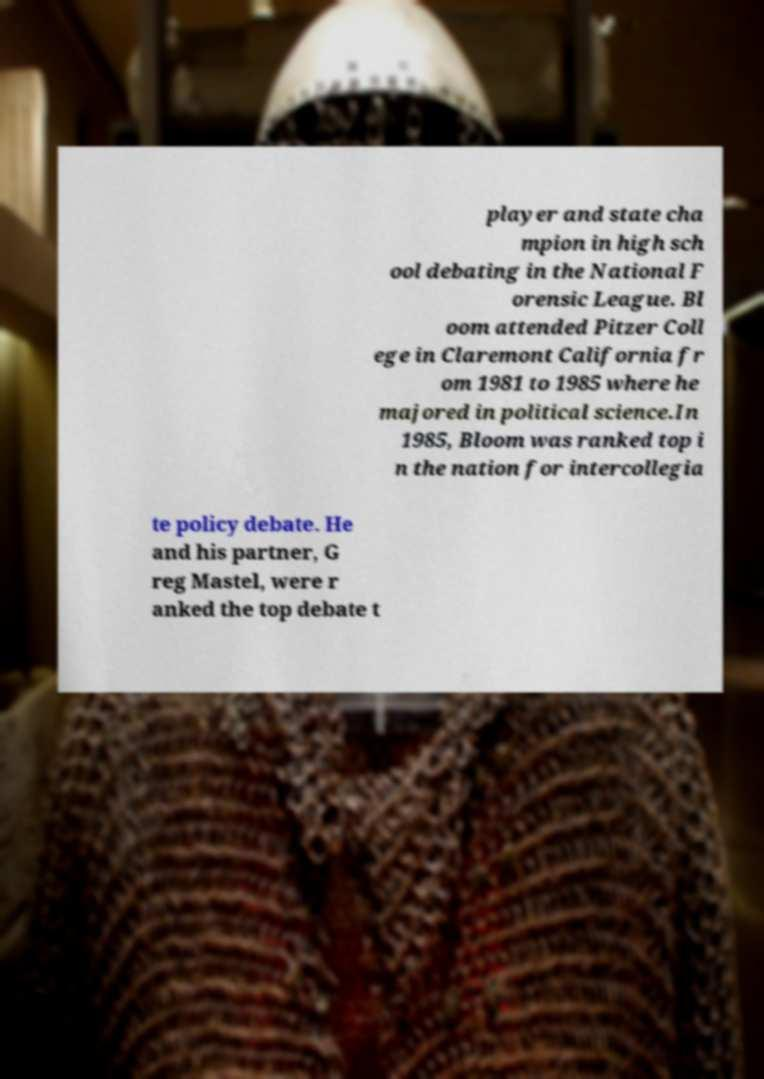Please read and relay the text visible in this image. What does it say? player and state cha mpion in high sch ool debating in the National F orensic League. Bl oom attended Pitzer Coll ege in Claremont California fr om 1981 to 1985 where he majored in political science.In 1985, Bloom was ranked top i n the nation for intercollegia te policy debate. He and his partner, G reg Mastel, were r anked the top debate t 